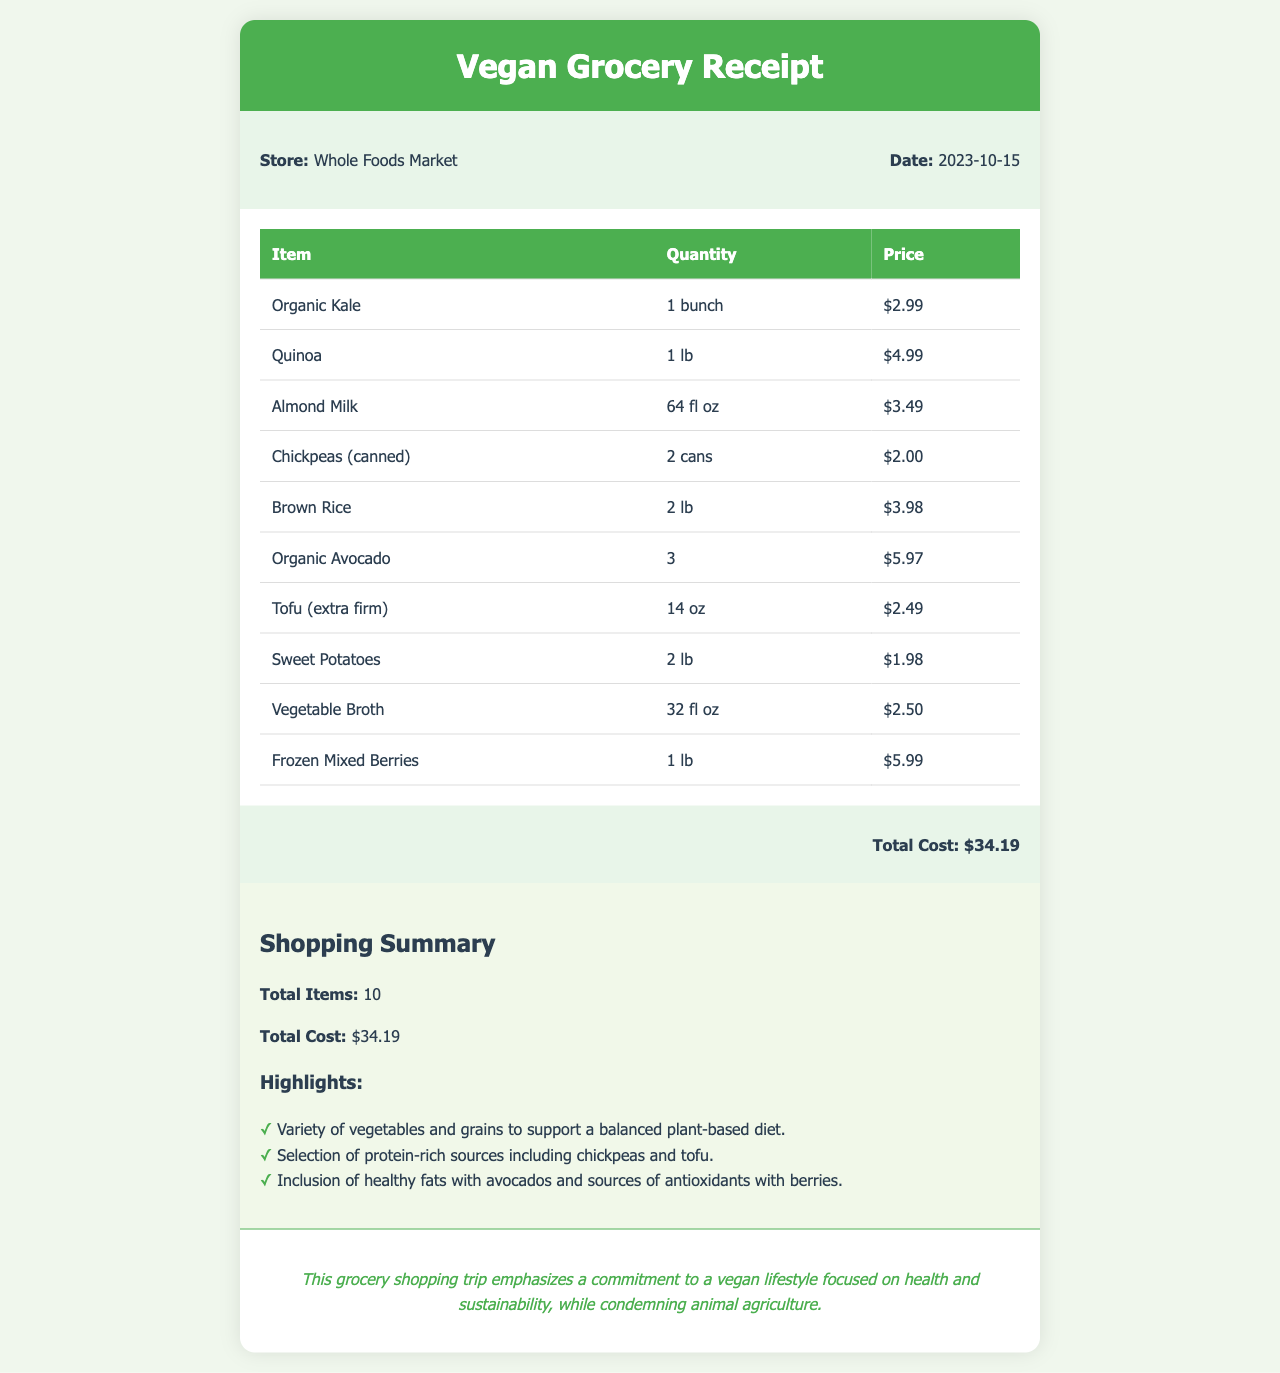What is the date of the grocery shopping trip? The date of the shopping trip is located in the receipt details section.
Answer: 2023-10-15 What is the total cost of the groceries? The total cost is indicated at the bottom of the receipt.
Answer: $34.19 How many cans of chickpeas were purchased? The quantity of chickpeas is listed in the items table.
Answer: 2 cans What store was the shopping trip made at? The name of the store is provided in the receipt details section.
Answer: Whole Foods Market Which protein-rich sources are included in the shopping summary? The highlights in the summary mention specific protein sources from the purchased items.
Answer: chickpeas and tofu How many items were purchased in total? The total number of items is mentioned in the shopping summary.
Answer: 10 What is one of the highlights listed in the shopping summary? The highlights section contains several points regarding the grocery choices.
Answer: Variety of vegetables and grains to support a balanced plant-based diet What is the type of tofu purchased? The specific type of tofu is mentioned in the items table.
Answer: extra firm Which healthy fat source is included in the shopping list? The items listed provide information on healthy fats in the summary section.
Answer: avocados 